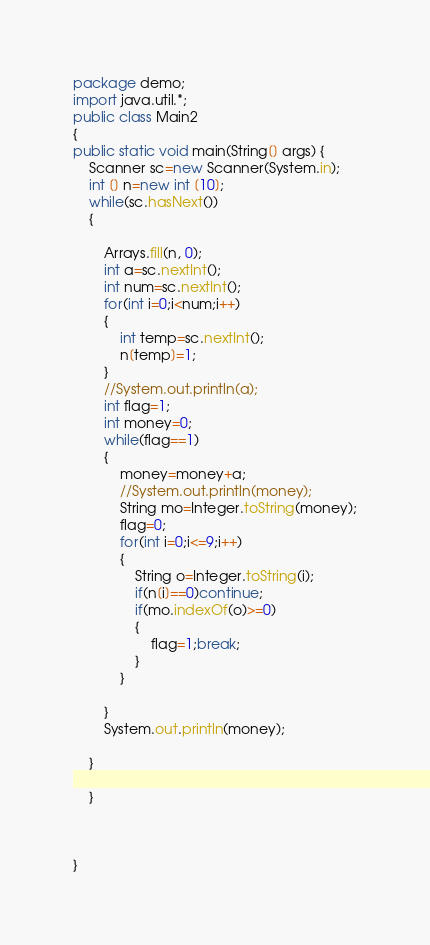<code> <loc_0><loc_0><loc_500><loc_500><_Java_>package demo;
import java.util.*;
public class Main2
{
public static void main(String[] args) {
	Scanner sc=new Scanner(System.in);
	int [] n=new int [10];
	while(sc.hasNext())
	{
		
		Arrays.fill(n, 0);
		int a=sc.nextInt();
		int num=sc.nextInt();
		for(int i=0;i<num;i++)
		{
			int temp=sc.nextInt();
			n[temp]=1;
		}
		//System.out.println(a);
		int flag=1;
		int money=0;
		while(flag==1)
		{
			money=money+a;
			//System.out.println(money);
			String mo=Integer.toString(money);
			flag=0;
			for(int i=0;i<=9;i++)
			{
				String o=Integer.toString(i);
				if(n[i]==0)continue;
				if(mo.indexOf(o)>=0)
				{
					flag=1;break;
				}
			}

		}
		System.out.println(money);
	
	}
		
	}
		


}</code> 